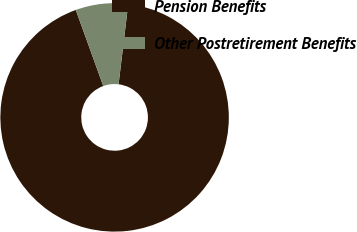Convert chart. <chart><loc_0><loc_0><loc_500><loc_500><pie_chart><fcel>Pension Benefits<fcel>Other Postretirement Benefits<nl><fcel>92.58%<fcel>7.42%<nl></chart> 